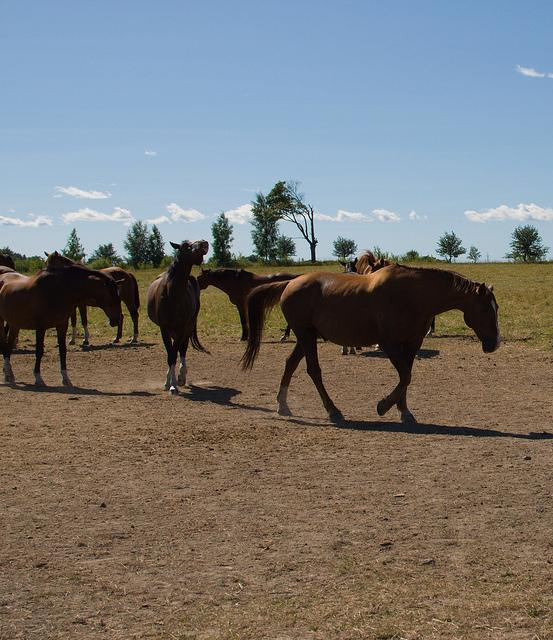This slowly moving horse is doing what?

Choices:
A) standing
B) trotting
C) springing
D) sitting trotting 